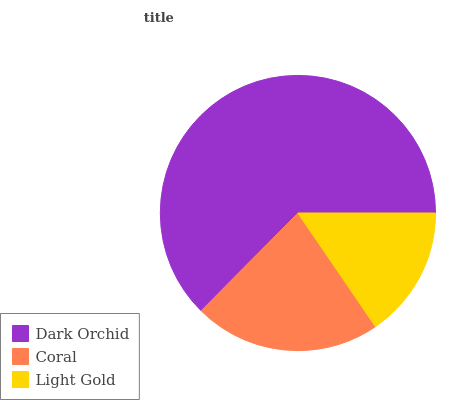Is Light Gold the minimum?
Answer yes or no. Yes. Is Dark Orchid the maximum?
Answer yes or no. Yes. Is Coral the minimum?
Answer yes or no. No. Is Coral the maximum?
Answer yes or no. No. Is Dark Orchid greater than Coral?
Answer yes or no. Yes. Is Coral less than Dark Orchid?
Answer yes or no. Yes. Is Coral greater than Dark Orchid?
Answer yes or no. No. Is Dark Orchid less than Coral?
Answer yes or no. No. Is Coral the high median?
Answer yes or no. Yes. Is Coral the low median?
Answer yes or no. Yes. Is Dark Orchid the high median?
Answer yes or no. No. Is Light Gold the low median?
Answer yes or no. No. 